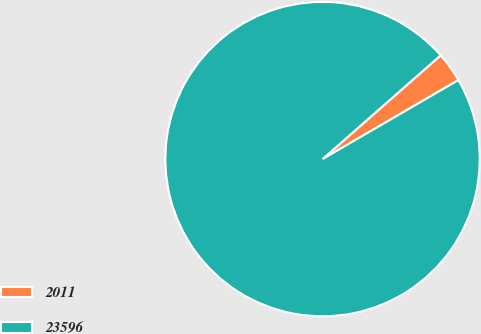Convert chart. <chart><loc_0><loc_0><loc_500><loc_500><pie_chart><fcel>2011<fcel>23596<nl><fcel>3.09%<fcel>96.91%<nl></chart> 